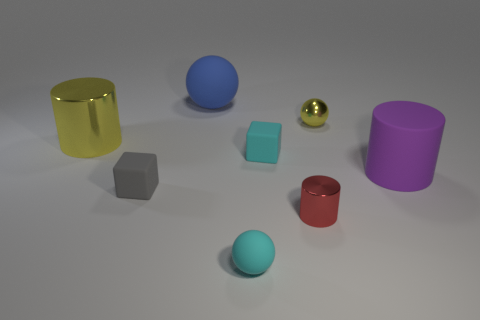Is there a red shiny block that has the same size as the red cylinder?
Provide a succinct answer. No. There is a blue object that is the same size as the yellow shiny cylinder; what is its material?
Make the answer very short. Rubber. How many small gray blocks are there?
Ensure brevity in your answer.  1. What size is the yellow object behind the big yellow shiny cylinder?
Offer a terse response. Small. Are there an equal number of cyan matte objects behind the small cyan ball and large blue rubber objects?
Your answer should be compact. Yes. Is there a blue rubber object that has the same shape as the gray rubber object?
Make the answer very short. No. There is a small thing that is behind the gray rubber thing and in front of the small yellow shiny ball; what shape is it?
Give a very brief answer. Cube. Is the gray block made of the same material as the cyan thing that is in front of the purple thing?
Give a very brief answer. Yes. Are there any shiny objects to the right of the large purple rubber thing?
Make the answer very short. No. How many objects are either blue matte balls or tiny things that are to the left of the tiny matte ball?
Make the answer very short. 2. 